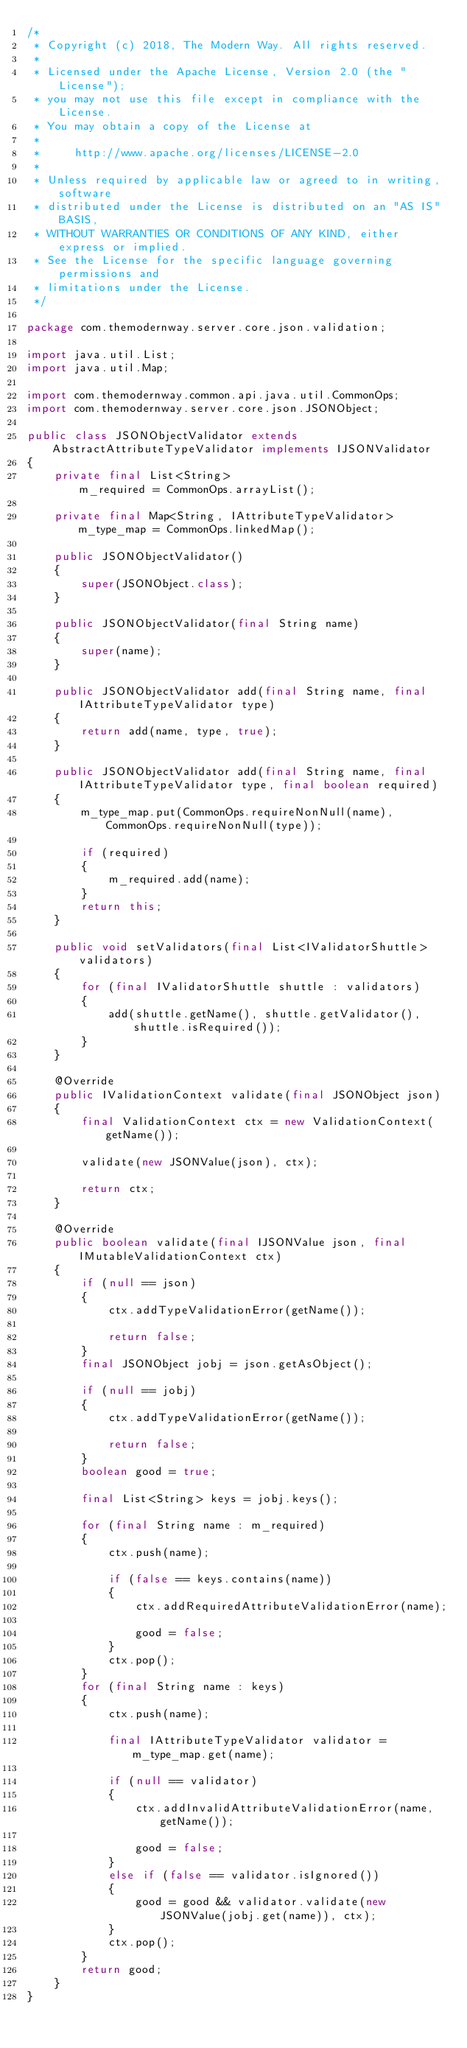Convert code to text. <code><loc_0><loc_0><loc_500><loc_500><_Java_>/*
 * Copyright (c) 2018, The Modern Way. All rights reserved.
 *
 * Licensed under the Apache License, Version 2.0 (the "License");
 * you may not use this file except in compliance with the License.
 * You may obtain a copy of the License at
 *
 *     http://www.apache.org/licenses/LICENSE-2.0
 *
 * Unless required by applicable law or agreed to in writing, software
 * distributed under the License is distributed on an "AS IS" BASIS,
 * WITHOUT WARRANTIES OR CONDITIONS OF ANY KIND, either express or implied.
 * See the License for the specific language governing permissions and
 * limitations under the License.
 */

package com.themodernway.server.core.json.validation;

import java.util.List;
import java.util.Map;

import com.themodernway.common.api.java.util.CommonOps;
import com.themodernway.server.core.json.JSONObject;

public class JSONObjectValidator extends AbstractAttributeTypeValidator implements IJSONValidator
{
    private final List<String>                         m_required = CommonOps.arrayList();

    private final Map<String, IAttributeTypeValidator> m_type_map = CommonOps.linkedMap();

    public JSONObjectValidator()
    {
        super(JSONObject.class);
    }

    public JSONObjectValidator(final String name)
    {
        super(name);
    }

    public JSONObjectValidator add(final String name, final IAttributeTypeValidator type)
    {
        return add(name, type, true);
    }

    public JSONObjectValidator add(final String name, final IAttributeTypeValidator type, final boolean required)
    {
        m_type_map.put(CommonOps.requireNonNull(name), CommonOps.requireNonNull(type));

        if (required)
        {
            m_required.add(name);
        }
        return this;
    }

    public void setValidators(final List<IValidatorShuttle> validators)
    {
        for (final IValidatorShuttle shuttle : validators)
        {
            add(shuttle.getName(), shuttle.getValidator(), shuttle.isRequired());
        }
    }

    @Override
    public IValidationContext validate(final JSONObject json)
    {
        final ValidationContext ctx = new ValidationContext(getName());

        validate(new JSONValue(json), ctx);

        return ctx;
    }

    @Override
    public boolean validate(final IJSONValue json, final IMutableValidationContext ctx)
    {
        if (null == json)
        {
            ctx.addTypeValidationError(getName());

            return false;
        }
        final JSONObject jobj = json.getAsObject();

        if (null == jobj)
        {
            ctx.addTypeValidationError(getName());

            return false;
        }
        boolean good = true;

        final List<String> keys = jobj.keys();

        for (final String name : m_required)
        {
            ctx.push(name);

            if (false == keys.contains(name))
            {
                ctx.addRequiredAttributeValidationError(name);

                good = false;
            }
            ctx.pop();
        }
        for (final String name : keys)
        {
            ctx.push(name);

            final IAttributeTypeValidator validator = m_type_map.get(name);

            if (null == validator)
            {
                ctx.addInvalidAttributeValidationError(name, getName());

                good = false;
            }
            else if (false == validator.isIgnored())
            {
                good = good && validator.validate(new JSONValue(jobj.get(name)), ctx);
            }
            ctx.pop();
        }
        return good;
    }
}
</code> 